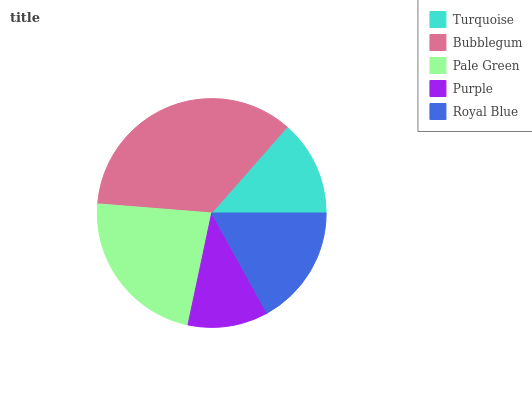Is Purple the minimum?
Answer yes or no. Yes. Is Bubblegum the maximum?
Answer yes or no. Yes. Is Pale Green the minimum?
Answer yes or no. No. Is Pale Green the maximum?
Answer yes or no. No. Is Bubblegum greater than Pale Green?
Answer yes or no. Yes. Is Pale Green less than Bubblegum?
Answer yes or no. Yes. Is Pale Green greater than Bubblegum?
Answer yes or no. No. Is Bubblegum less than Pale Green?
Answer yes or no. No. Is Royal Blue the high median?
Answer yes or no. Yes. Is Royal Blue the low median?
Answer yes or no. Yes. Is Turquoise the high median?
Answer yes or no. No. Is Purple the low median?
Answer yes or no. No. 